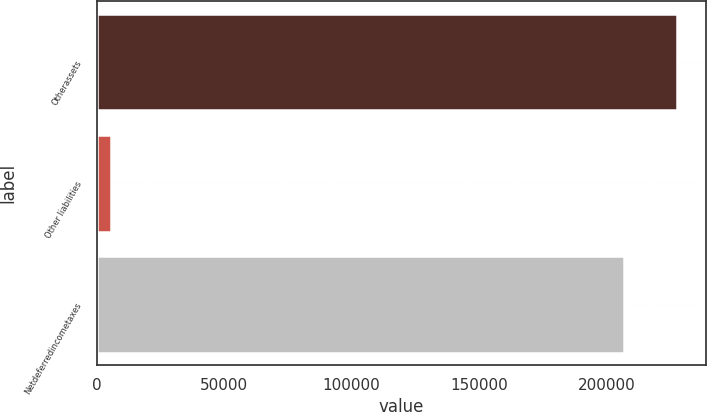Convert chart to OTSL. <chart><loc_0><loc_0><loc_500><loc_500><bar_chart><fcel>Otherassets<fcel>Other liabilities<fcel>Netdeferredincometaxes<nl><fcel>227552<fcel>5452<fcel>206865<nl></chart> 